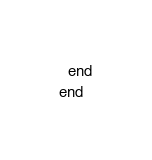Convert code to text. <code><loc_0><loc_0><loc_500><loc_500><_Ruby_>  end
end
</code> 